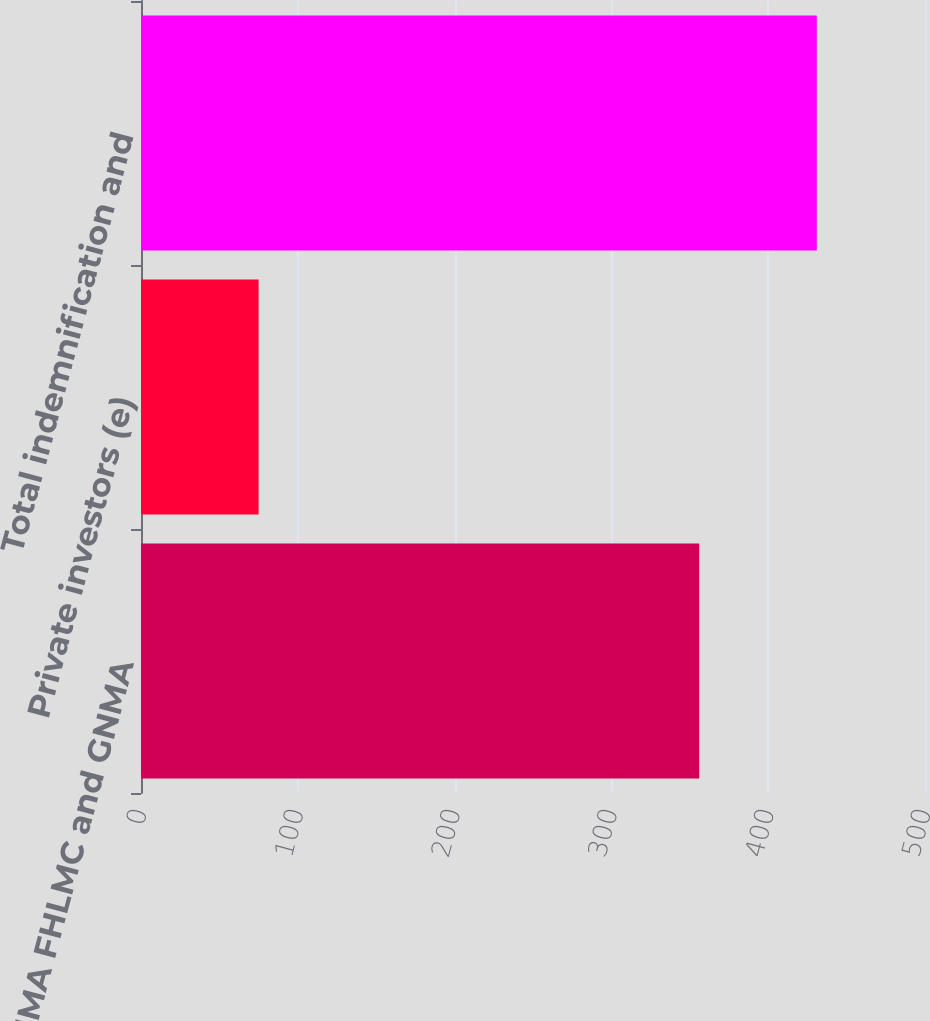Convert chart. <chart><loc_0><loc_0><loc_500><loc_500><bar_chart><fcel>FNMA FHLMC and GNMA<fcel>Private investors (e)<fcel>Total indemnification and<nl><fcel>356<fcel>75<fcel>431<nl></chart> 